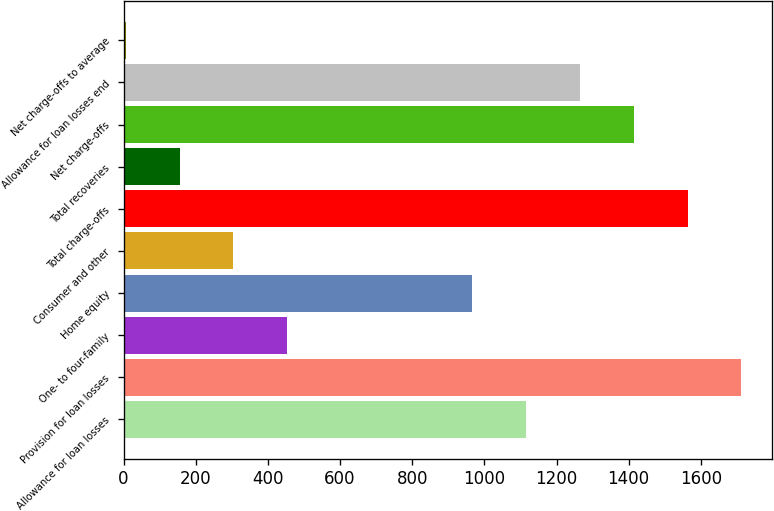<chart> <loc_0><loc_0><loc_500><loc_500><bar_chart><fcel>Allowance for loan losses<fcel>Provision for loan losses<fcel>One- to four-family<fcel>Home equity<fcel>Consumer and other<fcel>Total charge-offs<fcel>Total recoveries<fcel>Net charge-offs<fcel>Allowance for loan losses end<fcel>Net charge-offs to average<nl><fcel>1115.51<fcel>1712.35<fcel>453.67<fcel>966.3<fcel>304.46<fcel>1563.14<fcel>155.25<fcel>1413.93<fcel>1264.72<fcel>6.04<nl></chart> 